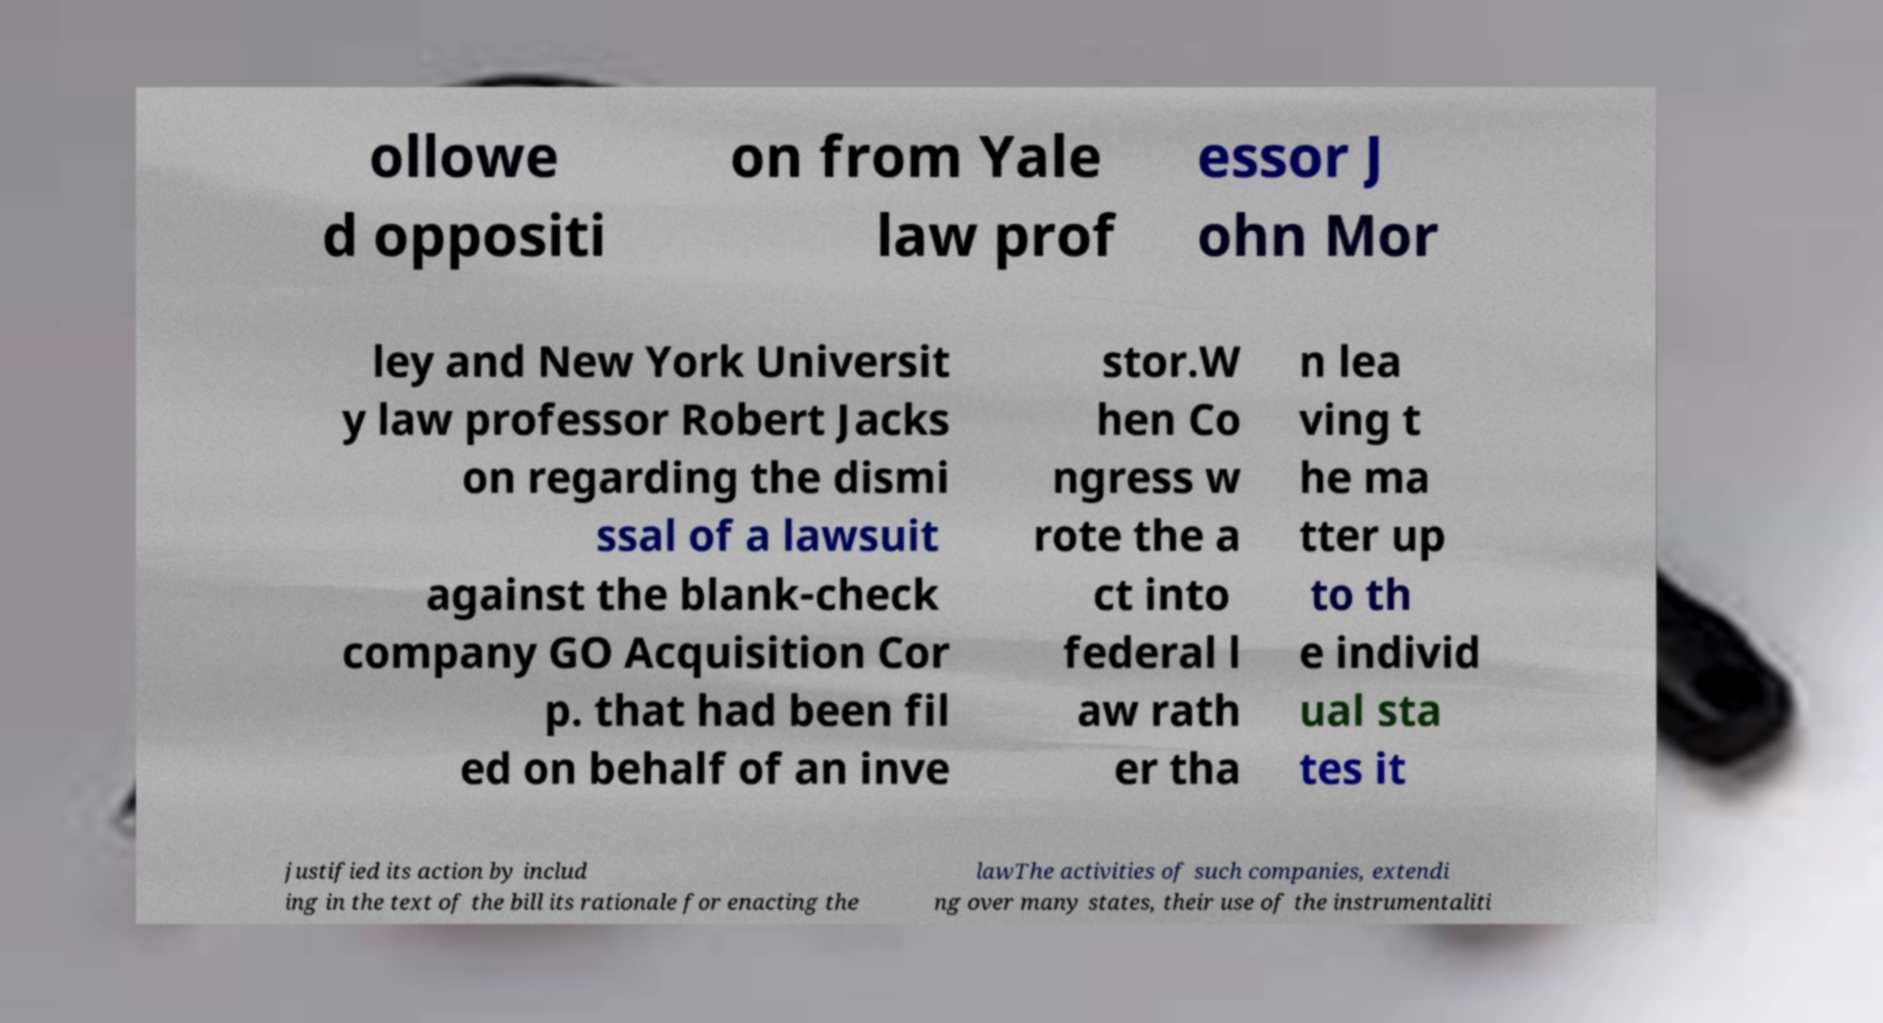What messages or text are displayed in this image? I need them in a readable, typed format. ollowe d oppositi on from Yale law prof essor J ohn Mor ley and New York Universit y law professor Robert Jacks on regarding the dismi ssal of a lawsuit against the blank-check company GO Acquisition Cor p. that had been fil ed on behalf of an inve stor.W hen Co ngress w rote the a ct into federal l aw rath er tha n lea ving t he ma tter up to th e individ ual sta tes it justified its action by includ ing in the text of the bill its rationale for enacting the lawThe activities of such companies, extendi ng over many states, their use of the instrumentaliti 